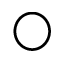<formula> <loc_0><loc_0><loc_500><loc_500>\bigcirc</formula> 